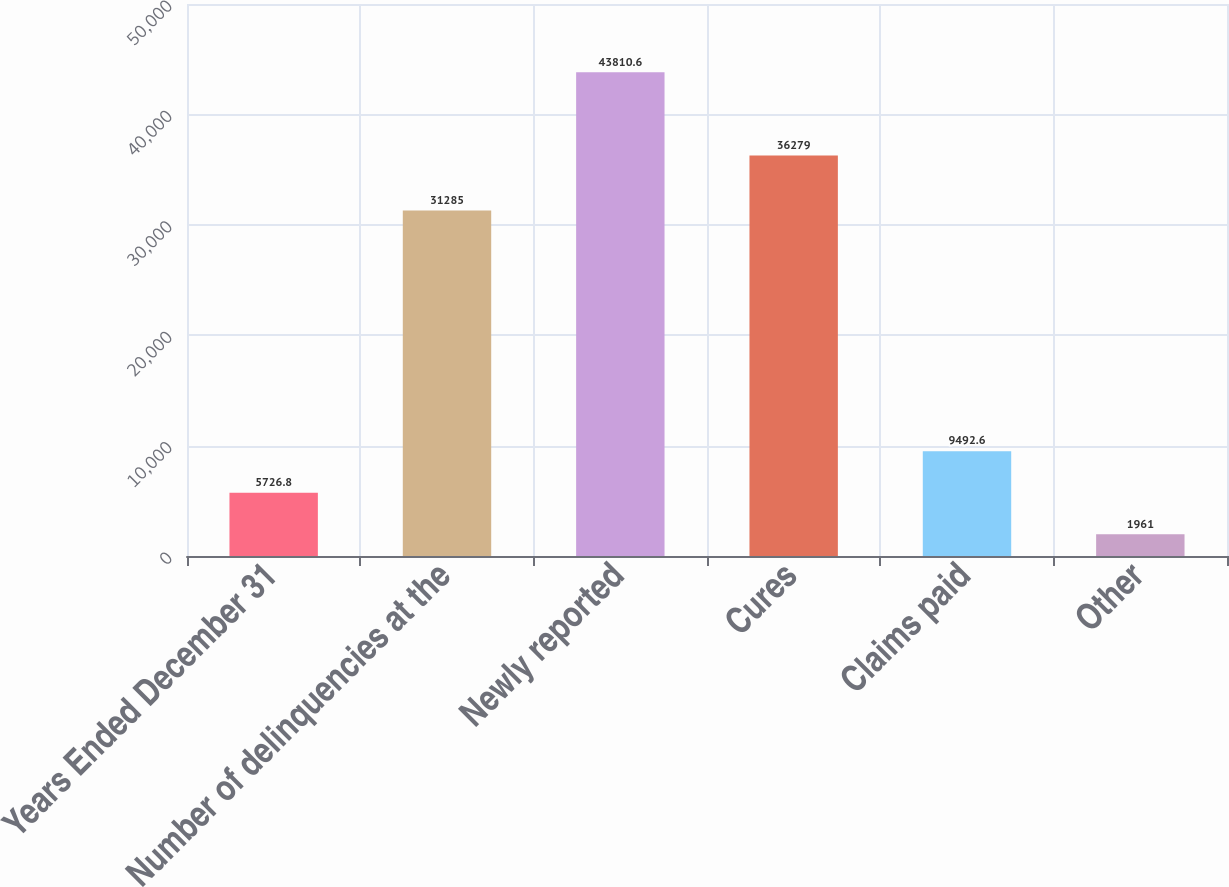<chart> <loc_0><loc_0><loc_500><loc_500><bar_chart><fcel>Years Ended December 31<fcel>Number of delinquencies at the<fcel>Newly reported<fcel>Cures<fcel>Claims paid<fcel>Other<nl><fcel>5726.8<fcel>31285<fcel>43810.6<fcel>36279<fcel>9492.6<fcel>1961<nl></chart> 